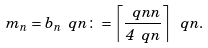<formula> <loc_0><loc_0><loc_500><loc_500>m _ { n } = b _ { n } \ q n \colon = \left \lceil \frac { \ q n n } { 4 \ q n } \right \rceil \ q n .</formula> 